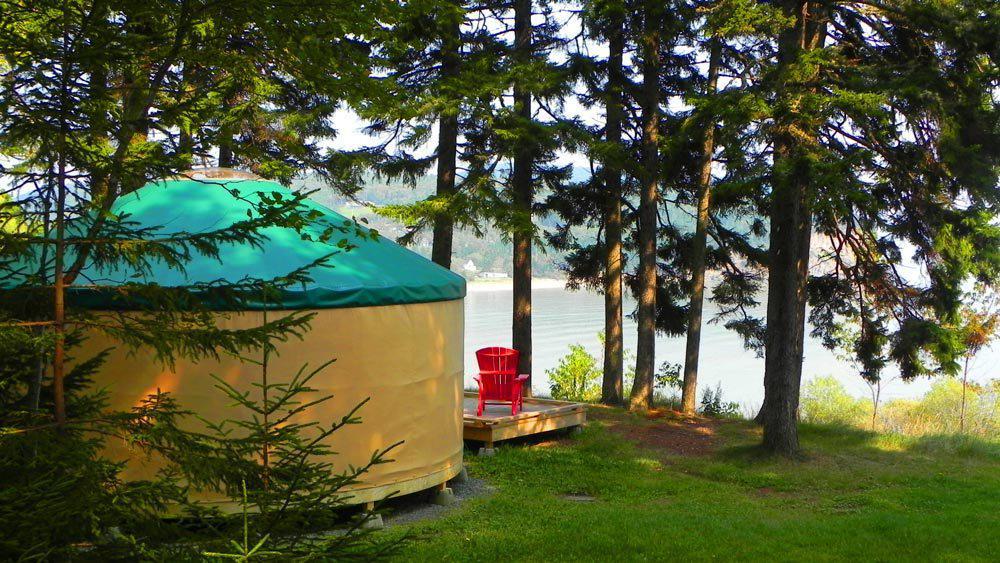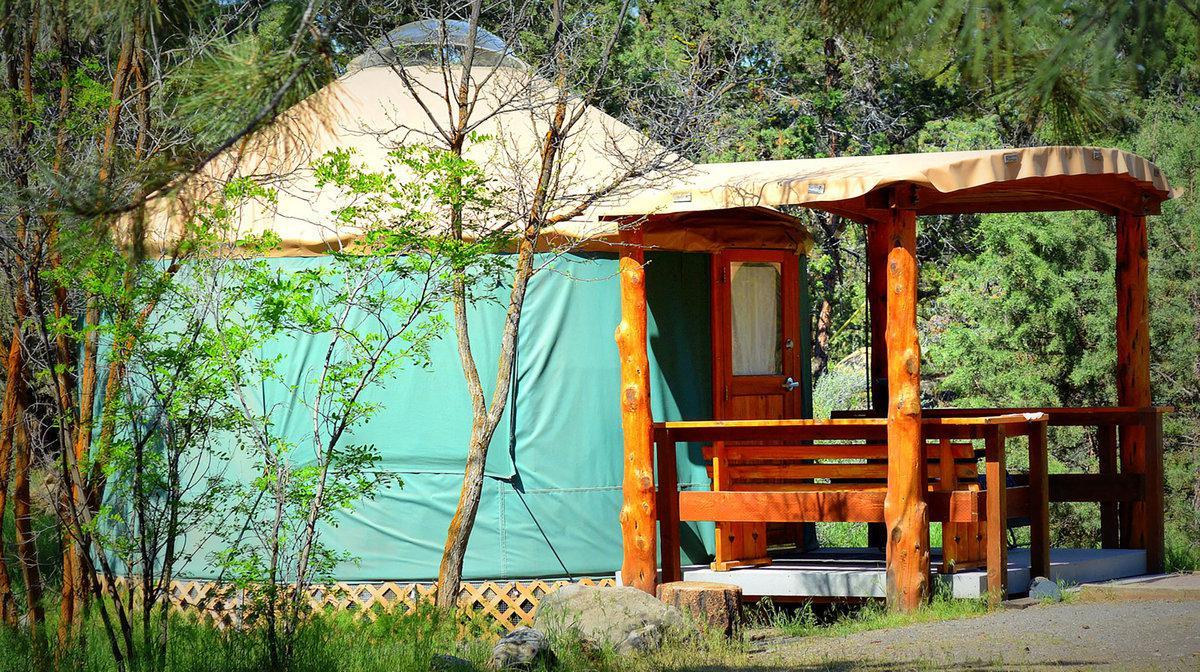The first image is the image on the left, the second image is the image on the right. For the images shown, is this caption "There is a covered wooden structure to the right of the yurt in the image on the right" true? Answer yes or no. Yes. The first image is the image on the left, the second image is the image on the right. Evaluate the accuracy of this statement regarding the images: "At least one round house has a wooden porch area with a roof.". Is it true? Answer yes or no. Yes. 